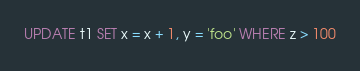Convert code to text. <code><loc_0><loc_0><loc_500><loc_500><_SQL_>UPDATE t1 SET x = x + 1, y = 'foo' WHERE z > 100
</code> 